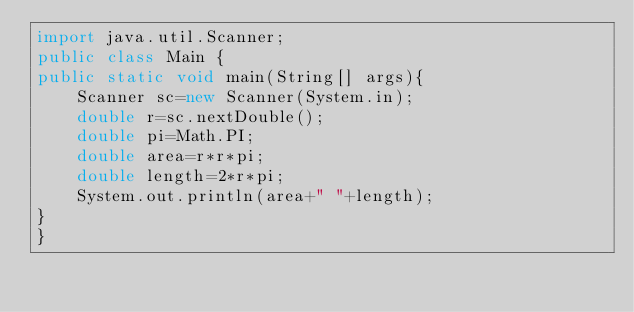<code> <loc_0><loc_0><loc_500><loc_500><_Java_>import java.util.Scanner;
public class Main {
public static void main(String[] args){
	Scanner sc=new Scanner(System.in);
	double r=sc.nextDouble();
	double pi=Math.PI;
	double area=r*r*pi;
	double length=2*r*pi;
	System.out.println(area+" "+length);
}
}</code> 